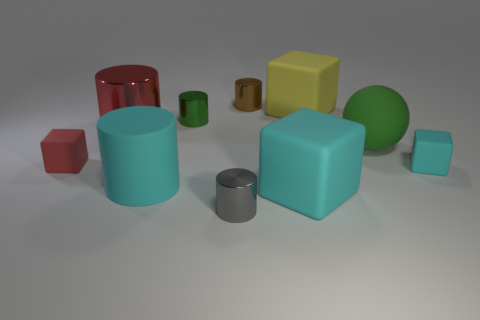Subtract all big cyan rubber blocks. How many blocks are left? 3 Subtract 3 blocks. How many blocks are left? 1 Subtract all red blocks. How many blocks are left? 3 Subtract all spheres. How many objects are left? 9 Subtract all big shiny spheres. Subtract all red metal things. How many objects are left? 9 Add 9 rubber cylinders. How many rubber cylinders are left? 10 Add 3 green things. How many green things exist? 5 Subtract 0 cyan balls. How many objects are left? 10 Subtract all purple balls. Subtract all cyan cubes. How many balls are left? 1 Subtract all gray cylinders. How many cyan cubes are left? 2 